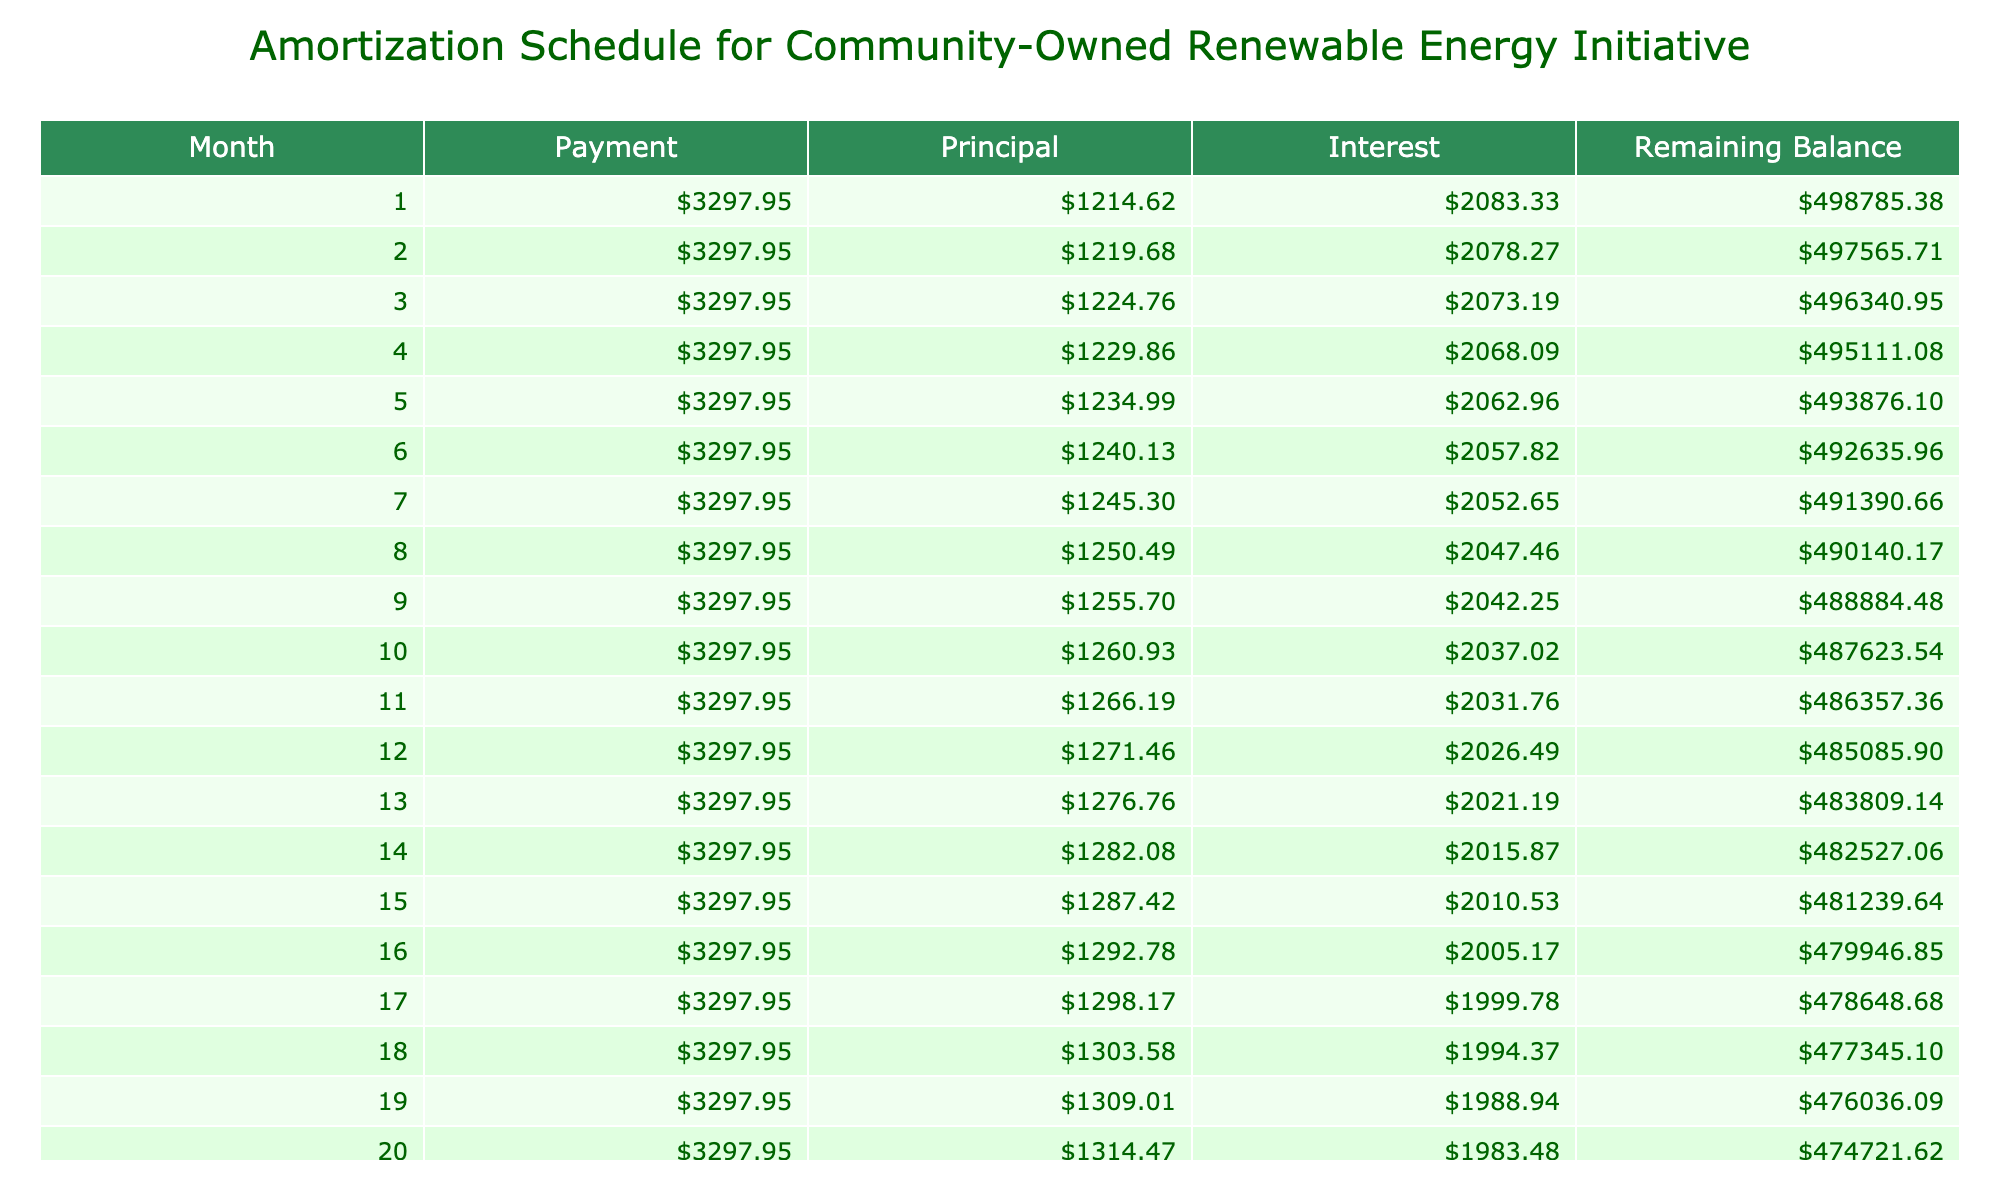What is the total amount to be paid over the life of the loan? The total payment is shown in the table under "Total Payment," which is $791,148.73.
Answer: $791,148.73 What is the monthly interest paid in the first month? To find this, look at the "Interest" column for the first month, which is $2,083.33.
Answer: $2,083.33 True or false: The total interest paid over the loan term exceeds $290,000. The table shows "Total Interest," which is $291,148.73. Since this amount is greater than $290,000, the statement is true.
Answer: True How much of the monthly payment goes towards the principal in the last month? The "Principal" amount for the last month is provided in the table. Since the loan does not fully amortize until the final payment, we can check the final row to see that the principal payment is $3,577.62.
Answer: $3,577.62 What is the average monthly payment over the life of the loan? The monthly payment is constant at $3,297.95 throughout the loan term, so the average monthly payment is also $3,297.95.
Answer: $3,297.95 How much is the balance after the first year? After 12 months, the remaining balance can be found in the table's fifth column for the 12th month, which shows a balance of $439,876.
Answer: $439,876.00 If the interest rate was reduced by 1%, what would be the new monthly payment? While this requires recalculating the monthly payment with the new interest rate, we can't derive that directly from the existing table. However, it can be said that a reduction would decrease the monthly payment significantly. Detailed calculations would need to be performed outside of this context.
Answer: Not directly available from the table What is the total principal paid at the halfway point of the loan? To find this, we need to sum the "Principal" column from month 1 to month 120 (or halfway, which is month 120). The estimated total at that point can be approximated but requires data from all those months. The table does not simplify this calculation just from the current view; it would be approximately $145,574.02 based on earlier monthly principal payments.
Answer: Approximately $145,574.02 